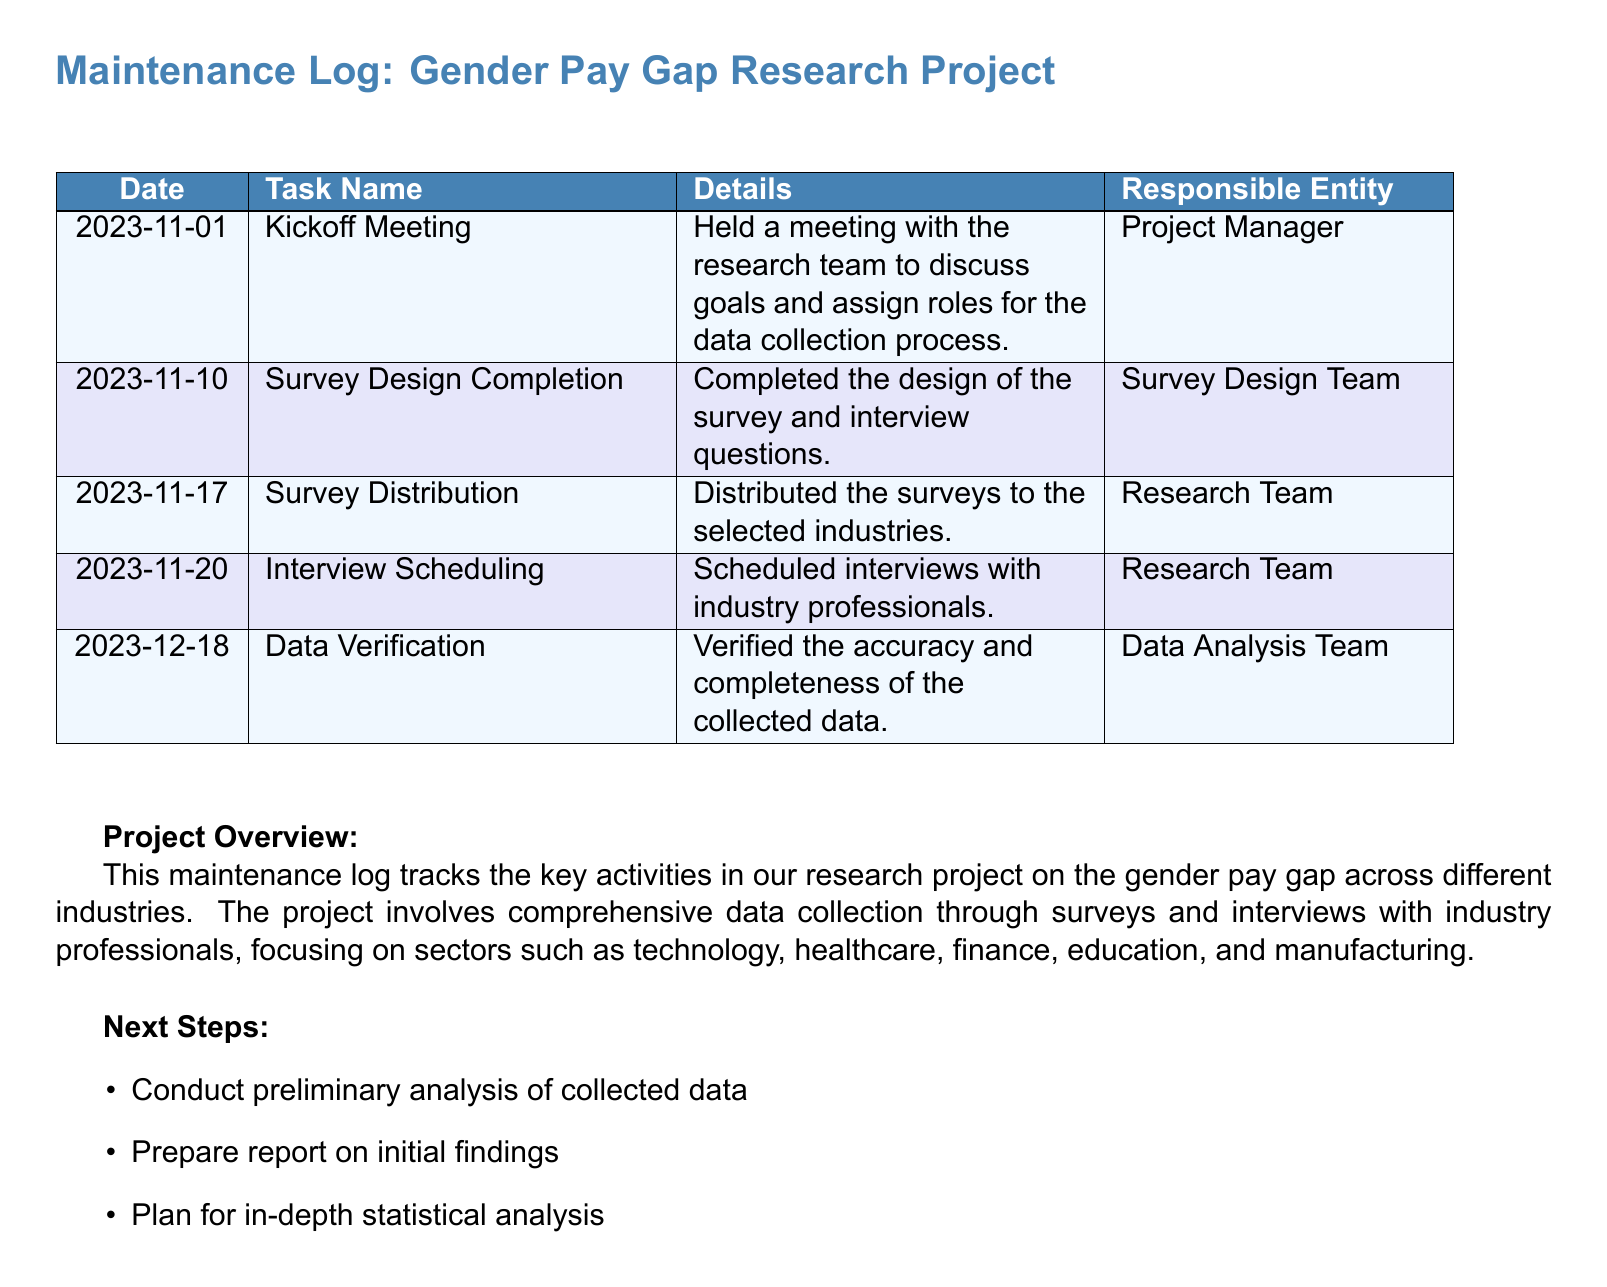What is the date of the kickoff meeting? The kickoff meeting took place on November 1, 2023, as indicated in the log.
Answer: November 1, 2023 Who is responsible for the survey design completion? The Survey Design Team is mentioned as the responsible entity for completing the survey design.
Answer: Survey Design Team What task occurred on December 18, 2023? The data verification task was carried out on this date as per the log details.
Answer: Data Verification How many days after the kickoff meeting was the survey distributed? The survey distribution took place on November 17, 2023, which is 16 days after the kickoff meeting.
Answer: 16 days What are the three next steps mentioned in the document? The next steps include conducting preliminary analysis, preparing a report, and planning in-depth analysis.
Answer: Conduct preliminary analysis, prepare report, plan for in-depth analysis What is the main focus of the research project? The main focus of the research project is on the gender pay gap across different industries.
Answer: Gender pay gap Which team is responsible for verifying data accuracy? The Data Analysis Team is specified as responsible for verifying the accuracy and completeness of the collected data.
Answer: Data Analysis Team What color represents the task details for survey distribution? The task details for survey distribution are represented by the color rowcolor1.
Answer: rowcolor1 When was the interview scheduling task performed? The interview scheduling task was performed on November 20, 2023.
Answer: November 20, 2023 